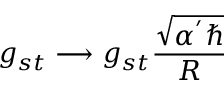<formula> <loc_0><loc_0><loc_500><loc_500>g _ { s t } \longrightarrow g _ { s t } \frac { \sqrt { \alpha ^ { ^ { \prime } } } } { R }</formula> 